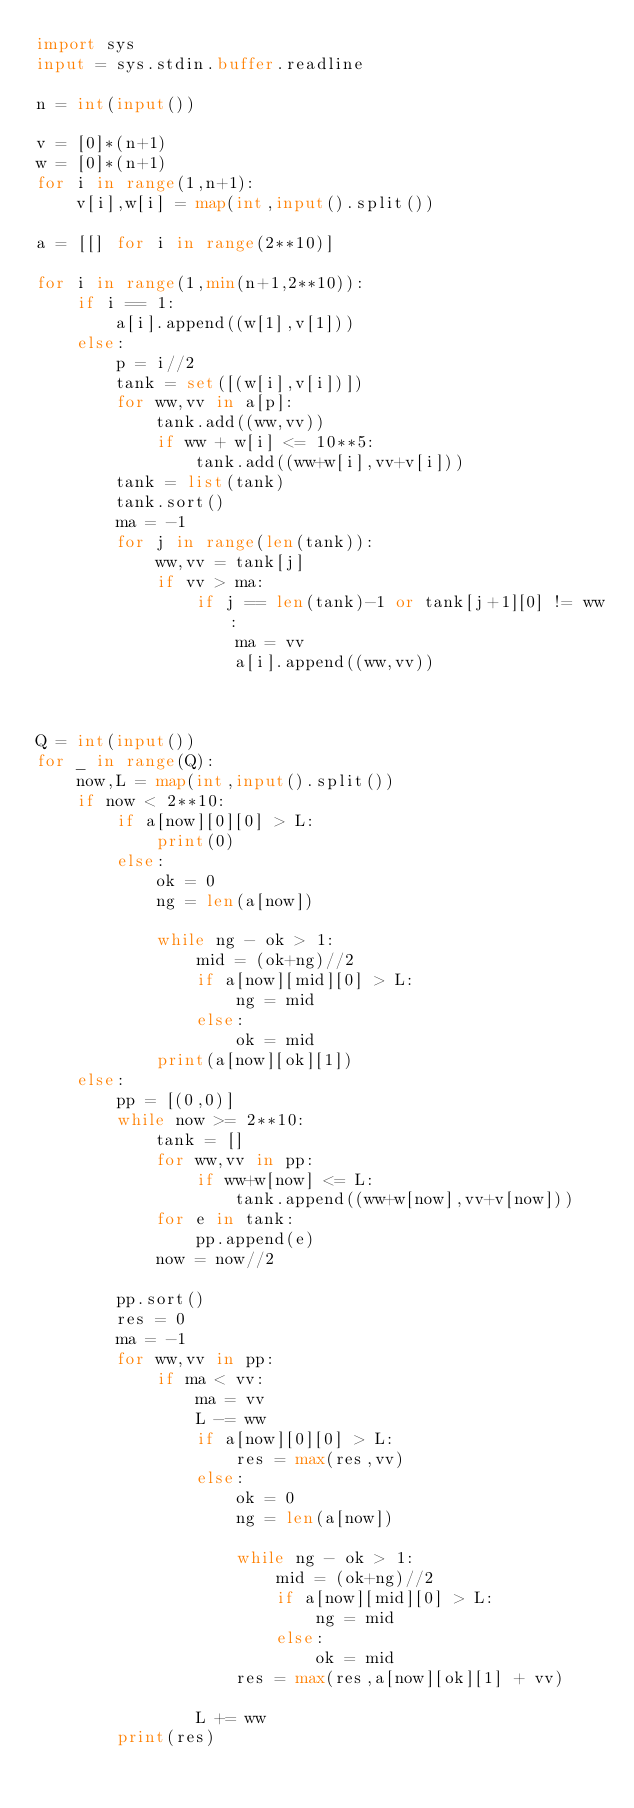Convert code to text. <code><loc_0><loc_0><loc_500><loc_500><_Python_>import sys
input = sys.stdin.buffer.readline

n = int(input())

v = [0]*(n+1)
w = [0]*(n+1)
for i in range(1,n+1):
    v[i],w[i] = map(int,input().split())

a = [[] for i in range(2**10)]

for i in range(1,min(n+1,2**10)):
    if i == 1:
        a[i].append((w[1],v[1]))
    else:
        p = i//2
        tank = set([(w[i],v[i])])
        for ww,vv in a[p]:
            tank.add((ww,vv))
            if ww + w[i] <= 10**5:
                tank.add((ww+w[i],vv+v[i]))
        tank = list(tank)
        tank.sort()
        ma = -1
        for j in range(len(tank)):
            ww,vv = tank[j]
            if vv > ma:
                if j == len(tank)-1 or tank[j+1][0] != ww:
                    ma = vv
                    a[i].append((ww,vv))



Q = int(input())
for _ in range(Q):
    now,L = map(int,input().split())
    if now < 2**10:
        if a[now][0][0] > L:
            print(0)
        else:
            ok = 0
            ng = len(a[now])

            while ng - ok > 1:
                mid = (ok+ng)//2
                if a[now][mid][0] > L:
                    ng = mid
                else:
                    ok = mid
            print(a[now][ok][1])
    else:
        pp = [(0,0)]
        while now >= 2**10:
            tank = []
            for ww,vv in pp:
                if ww+w[now] <= L:
                    tank.append((ww+w[now],vv+v[now]))
            for e in tank:
                pp.append(e)
            now = now//2

        pp.sort()
        res = 0
        ma = -1
        for ww,vv in pp:
            if ma < vv:
                ma = vv
                L -= ww
                if a[now][0][0] > L:
                    res = max(res,vv)
                else:
                    ok = 0
                    ng = len(a[now])

                    while ng - ok > 1:
                        mid = (ok+ng)//2
                        if a[now][mid][0] > L:
                            ng = mid
                        else:
                            ok = mid
                    res = max(res,a[now][ok][1] + vv)

                L += ww
        print(res)
</code> 